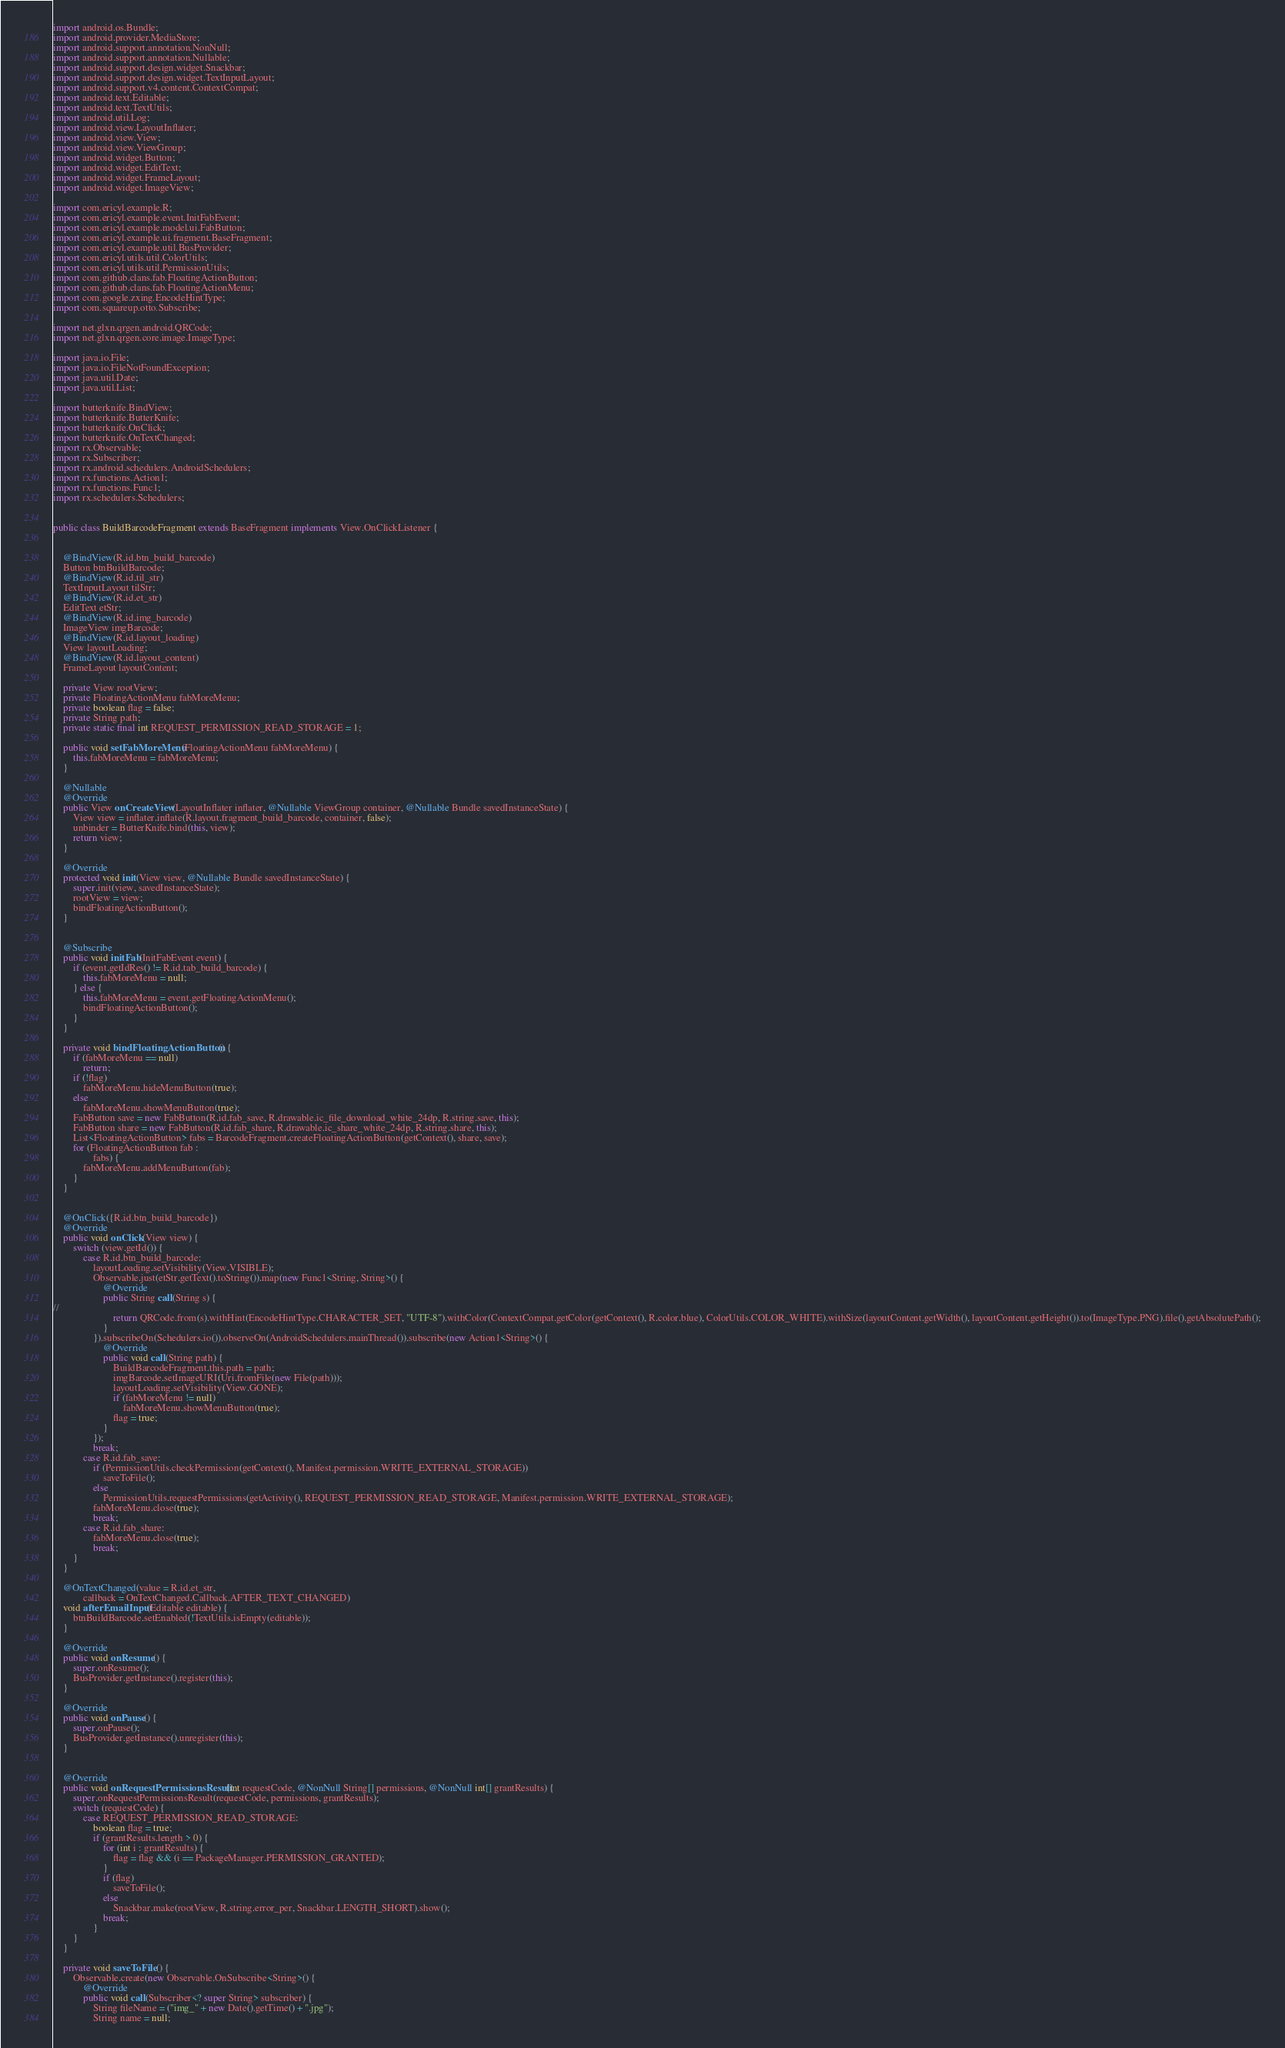Convert code to text. <code><loc_0><loc_0><loc_500><loc_500><_Java_>import android.os.Bundle;
import android.provider.MediaStore;
import android.support.annotation.NonNull;
import android.support.annotation.Nullable;
import android.support.design.widget.Snackbar;
import android.support.design.widget.TextInputLayout;
import android.support.v4.content.ContextCompat;
import android.text.Editable;
import android.text.TextUtils;
import android.util.Log;
import android.view.LayoutInflater;
import android.view.View;
import android.view.ViewGroup;
import android.widget.Button;
import android.widget.EditText;
import android.widget.FrameLayout;
import android.widget.ImageView;

import com.ericyl.example.R;
import com.ericyl.example.event.InitFabEvent;
import com.ericyl.example.model.ui.FabButton;
import com.ericyl.example.ui.fragment.BaseFragment;
import com.ericyl.example.util.BusProvider;
import com.ericyl.utils.util.ColorUtils;
import com.ericyl.utils.util.PermissionUtils;
import com.github.clans.fab.FloatingActionButton;
import com.github.clans.fab.FloatingActionMenu;
import com.google.zxing.EncodeHintType;
import com.squareup.otto.Subscribe;

import net.glxn.qrgen.android.QRCode;
import net.glxn.qrgen.core.image.ImageType;

import java.io.File;
import java.io.FileNotFoundException;
import java.util.Date;
import java.util.List;

import butterknife.BindView;
import butterknife.ButterKnife;
import butterknife.OnClick;
import butterknife.OnTextChanged;
import rx.Observable;
import rx.Subscriber;
import rx.android.schedulers.AndroidSchedulers;
import rx.functions.Action1;
import rx.functions.Func1;
import rx.schedulers.Schedulers;


public class BuildBarcodeFragment extends BaseFragment implements View.OnClickListener {


    @BindView(R.id.btn_build_barcode)
    Button btnBuildBarcode;
    @BindView(R.id.til_str)
    TextInputLayout tilStr;
    @BindView(R.id.et_str)
    EditText etStr;
    @BindView(R.id.img_barcode)
    ImageView imgBarcode;
    @BindView(R.id.layout_loading)
    View layoutLoading;
    @BindView(R.id.layout_content)
    FrameLayout layoutContent;

    private View rootView;
    private FloatingActionMenu fabMoreMenu;
    private boolean flag = false;
    private String path;
    private static final int REQUEST_PERMISSION_READ_STORAGE = 1;

    public void setFabMoreMenu(FloatingActionMenu fabMoreMenu) {
        this.fabMoreMenu = fabMoreMenu;
    }

    @Nullable
    @Override
    public View onCreateView(LayoutInflater inflater, @Nullable ViewGroup container, @Nullable Bundle savedInstanceState) {
        View view = inflater.inflate(R.layout.fragment_build_barcode, container, false);
        unbinder = ButterKnife.bind(this, view);
        return view;
    }

    @Override
    protected void init(View view, @Nullable Bundle savedInstanceState) {
        super.init(view, savedInstanceState);
        rootView = view;
        bindFloatingActionButton();
    }


    @Subscribe
    public void initFab(InitFabEvent event) {
        if (event.getIdRes() != R.id.tab_build_barcode) {
            this.fabMoreMenu = null;
        } else {
            this.fabMoreMenu = event.getFloatingActionMenu();
            bindFloatingActionButton();
        }
    }

    private void bindFloatingActionButton() {
        if (fabMoreMenu == null)
            return;
        if (!flag)
            fabMoreMenu.hideMenuButton(true);
        else
            fabMoreMenu.showMenuButton(true);
        FabButton save = new FabButton(R.id.fab_save, R.drawable.ic_file_download_white_24dp, R.string.save, this);
        FabButton share = new FabButton(R.id.fab_share, R.drawable.ic_share_white_24dp, R.string.share, this);
        List<FloatingActionButton> fabs = BarcodeFragment.createFloatingActionButton(getContext(), share, save);
        for (FloatingActionButton fab :
                fabs) {
            fabMoreMenu.addMenuButton(fab);
        }
    }


    @OnClick({R.id.btn_build_barcode})
    @Override
    public void onClick(View view) {
        switch (view.getId()) {
            case R.id.btn_build_barcode:
                layoutLoading.setVisibility(View.VISIBLE);
                Observable.just(etStr.getText().toString()).map(new Func1<String, String>() {
                    @Override
                    public String call(String s) {
//
                        return QRCode.from(s).withHint(EncodeHintType.CHARACTER_SET, "UTF-8").withColor(ContextCompat.getColor(getContext(), R.color.blue), ColorUtils.COLOR_WHITE).withSize(layoutContent.getWidth(), layoutContent.getHeight()).to(ImageType.PNG).file().getAbsolutePath();
                    }
                }).subscribeOn(Schedulers.io()).observeOn(AndroidSchedulers.mainThread()).subscribe(new Action1<String>() {
                    @Override
                    public void call(String path) {
                        BuildBarcodeFragment.this.path = path;
                        imgBarcode.setImageURI(Uri.fromFile(new File(path)));
                        layoutLoading.setVisibility(View.GONE);
                        if (fabMoreMenu != null)
                            fabMoreMenu.showMenuButton(true);
                        flag = true;
                    }
                });
                break;
            case R.id.fab_save:
                if (PermissionUtils.checkPermission(getContext(), Manifest.permission.WRITE_EXTERNAL_STORAGE))
                    saveToFile();
                else
                    PermissionUtils.requestPermissions(getActivity(), REQUEST_PERMISSION_READ_STORAGE, Manifest.permission.WRITE_EXTERNAL_STORAGE);
                fabMoreMenu.close(true);
                break;
            case R.id.fab_share:
                fabMoreMenu.close(true);
                break;
        }
    }

    @OnTextChanged(value = R.id.et_str,
            callback = OnTextChanged.Callback.AFTER_TEXT_CHANGED)
    void afterEmailInput(Editable editable) {
        btnBuildBarcode.setEnabled(!TextUtils.isEmpty(editable));
    }

    @Override
    public void onResume() {
        super.onResume();
        BusProvider.getInstance().register(this);
    }

    @Override
    public void onPause() {
        super.onPause();
        BusProvider.getInstance().unregister(this);
    }


    @Override
    public void onRequestPermissionsResult(int requestCode, @NonNull String[] permissions, @NonNull int[] grantResults) {
        super.onRequestPermissionsResult(requestCode, permissions, grantResults);
        switch (requestCode) {
            case REQUEST_PERMISSION_READ_STORAGE:
                boolean flag = true;
                if (grantResults.length > 0) {
                    for (int i : grantResults) {
                        flag = flag && (i == PackageManager.PERMISSION_GRANTED);
                    }
                    if (flag)
                        saveToFile();
                    else
                        Snackbar.make(rootView, R.string.error_per, Snackbar.LENGTH_SHORT).show();
                    break;
                }
        }
    }

    private void saveToFile() {
        Observable.create(new Observable.OnSubscribe<String>() {
            @Override
            public void call(Subscriber<? super String> subscriber) {
                String fileName = ("img_" + new Date().getTime() + ".jpg");
                String name = null;</code> 